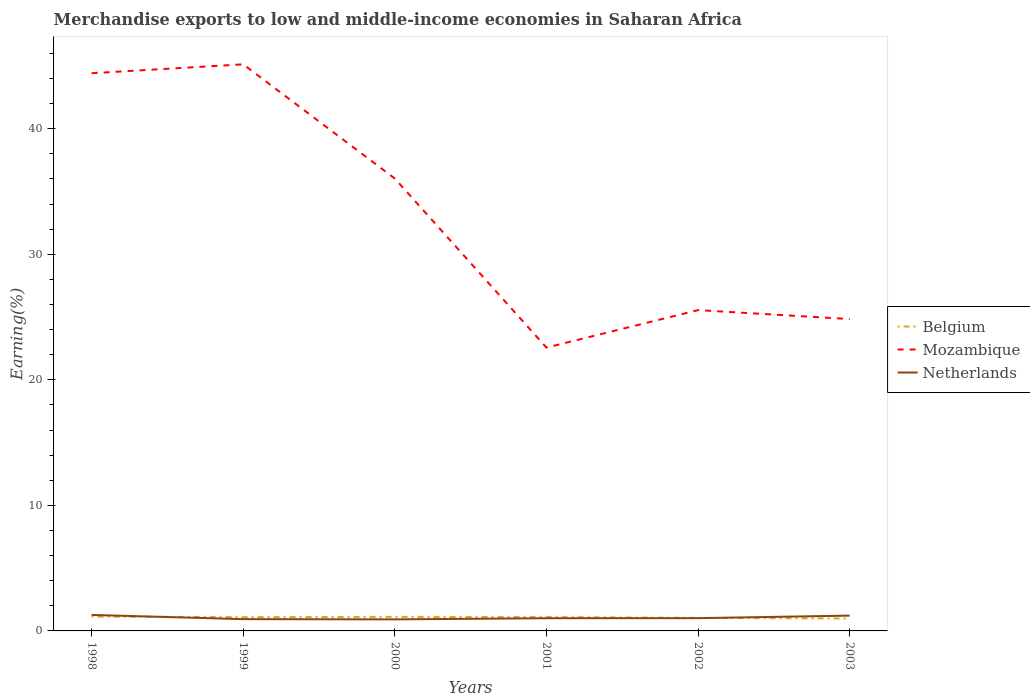Does the line corresponding to Netherlands intersect with the line corresponding to Mozambique?
Make the answer very short. No. Is the number of lines equal to the number of legend labels?
Offer a terse response. Yes. Across all years, what is the maximum percentage of amount earned from merchandise exports in Netherlands?
Keep it short and to the point. 0.92. In which year was the percentage of amount earned from merchandise exports in Belgium maximum?
Make the answer very short. 2003. What is the total percentage of amount earned from merchandise exports in Mozambique in the graph?
Your answer should be very brief. 19.58. What is the difference between the highest and the second highest percentage of amount earned from merchandise exports in Netherlands?
Your answer should be very brief. 0.35. How many lines are there?
Give a very brief answer. 3. Are the values on the major ticks of Y-axis written in scientific E-notation?
Offer a terse response. No. Does the graph contain grids?
Offer a very short reply. No. How are the legend labels stacked?
Give a very brief answer. Vertical. What is the title of the graph?
Offer a terse response. Merchandise exports to low and middle-income economies in Saharan Africa. What is the label or title of the Y-axis?
Ensure brevity in your answer.  Earning(%). What is the Earning(%) of Belgium in 1998?
Give a very brief answer. 1.15. What is the Earning(%) in Mozambique in 1998?
Your answer should be compact. 44.42. What is the Earning(%) of Netherlands in 1998?
Offer a terse response. 1.27. What is the Earning(%) of Belgium in 1999?
Your answer should be very brief. 1.09. What is the Earning(%) of Mozambique in 1999?
Give a very brief answer. 45.13. What is the Earning(%) of Netherlands in 1999?
Your answer should be compact. 0.94. What is the Earning(%) in Belgium in 2000?
Offer a very short reply. 1.12. What is the Earning(%) of Mozambique in 2000?
Keep it short and to the point. 36.03. What is the Earning(%) in Netherlands in 2000?
Give a very brief answer. 0.92. What is the Earning(%) in Belgium in 2001?
Provide a short and direct response. 1.1. What is the Earning(%) of Mozambique in 2001?
Your answer should be very brief. 22.57. What is the Earning(%) in Netherlands in 2001?
Give a very brief answer. 1.01. What is the Earning(%) in Belgium in 2002?
Provide a short and direct response. 1.04. What is the Earning(%) in Mozambique in 2002?
Provide a short and direct response. 25.55. What is the Earning(%) of Netherlands in 2002?
Ensure brevity in your answer.  1.02. What is the Earning(%) of Belgium in 2003?
Your answer should be very brief. 0.99. What is the Earning(%) in Mozambique in 2003?
Your response must be concise. 24.84. What is the Earning(%) in Netherlands in 2003?
Provide a succinct answer. 1.22. Across all years, what is the maximum Earning(%) of Belgium?
Keep it short and to the point. 1.15. Across all years, what is the maximum Earning(%) of Mozambique?
Make the answer very short. 45.13. Across all years, what is the maximum Earning(%) of Netherlands?
Provide a short and direct response. 1.27. Across all years, what is the minimum Earning(%) of Belgium?
Your response must be concise. 0.99. Across all years, what is the minimum Earning(%) in Mozambique?
Offer a terse response. 22.57. Across all years, what is the minimum Earning(%) in Netherlands?
Offer a terse response. 0.92. What is the total Earning(%) of Belgium in the graph?
Provide a short and direct response. 6.49. What is the total Earning(%) in Mozambique in the graph?
Provide a succinct answer. 198.54. What is the total Earning(%) of Netherlands in the graph?
Give a very brief answer. 6.38. What is the difference between the Earning(%) in Belgium in 1998 and that in 1999?
Offer a very short reply. 0.05. What is the difference between the Earning(%) in Mozambique in 1998 and that in 1999?
Your answer should be compact. -0.71. What is the difference between the Earning(%) of Netherlands in 1998 and that in 1999?
Offer a very short reply. 0.33. What is the difference between the Earning(%) in Belgium in 1998 and that in 2000?
Make the answer very short. 0.02. What is the difference between the Earning(%) of Mozambique in 1998 and that in 2000?
Provide a short and direct response. 8.39. What is the difference between the Earning(%) of Netherlands in 1998 and that in 2000?
Your answer should be very brief. 0.35. What is the difference between the Earning(%) in Belgium in 1998 and that in 2001?
Offer a very short reply. 0.04. What is the difference between the Earning(%) in Mozambique in 1998 and that in 2001?
Provide a short and direct response. 21.85. What is the difference between the Earning(%) of Netherlands in 1998 and that in 2001?
Your answer should be very brief. 0.26. What is the difference between the Earning(%) in Belgium in 1998 and that in 2002?
Give a very brief answer. 0.11. What is the difference between the Earning(%) in Mozambique in 1998 and that in 2002?
Offer a very short reply. 18.87. What is the difference between the Earning(%) of Netherlands in 1998 and that in 2002?
Keep it short and to the point. 0.26. What is the difference between the Earning(%) of Belgium in 1998 and that in 2003?
Make the answer very short. 0.16. What is the difference between the Earning(%) in Mozambique in 1998 and that in 2003?
Ensure brevity in your answer.  19.58. What is the difference between the Earning(%) in Netherlands in 1998 and that in 2003?
Your response must be concise. 0.05. What is the difference between the Earning(%) of Belgium in 1999 and that in 2000?
Provide a short and direct response. -0.03. What is the difference between the Earning(%) of Mozambique in 1999 and that in 2000?
Ensure brevity in your answer.  9.1. What is the difference between the Earning(%) of Netherlands in 1999 and that in 2000?
Your response must be concise. 0.02. What is the difference between the Earning(%) in Belgium in 1999 and that in 2001?
Your response must be concise. -0.01. What is the difference between the Earning(%) in Mozambique in 1999 and that in 2001?
Ensure brevity in your answer.  22.56. What is the difference between the Earning(%) of Netherlands in 1999 and that in 2001?
Keep it short and to the point. -0.07. What is the difference between the Earning(%) of Belgium in 1999 and that in 2002?
Keep it short and to the point. 0.05. What is the difference between the Earning(%) of Mozambique in 1999 and that in 2002?
Keep it short and to the point. 19.58. What is the difference between the Earning(%) in Netherlands in 1999 and that in 2002?
Offer a very short reply. -0.08. What is the difference between the Earning(%) of Belgium in 1999 and that in 2003?
Make the answer very short. 0.11. What is the difference between the Earning(%) of Mozambique in 1999 and that in 2003?
Provide a succinct answer. 20.29. What is the difference between the Earning(%) of Netherlands in 1999 and that in 2003?
Make the answer very short. -0.28. What is the difference between the Earning(%) in Belgium in 2000 and that in 2001?
Your answer should be very brief. 0.02. What is the difference between the Earning(%) of Mozambique in 2000 and that in 2001?
Provide a succinct answer. 13.46. What is the difference between the Earning(%) in Netherlands in 2000 and that in 2001?
Offer a very short reply. -0.09. What is the difference between the Earning(%) of Belgium in 2000 and that in 2002?
Provide a short and direct response. 0.08. What is the difference between the Earning(%) of Mozambique in 2000 and that in 2002?
Your answer should be very brief. 10.48. What is the difference between the Earning(%) in Netherlands in 2000 and that in 2002?
Offer a terse response. -0.1. What is the difference between the Earning(%) of Belgium in 2000 and that in 2003?
Your response must be concise. 0.13. What is the difference between the Earning(%) in Mozambique in 2000 and that in 2003?
Provide a succinct answer. 11.19. What is the difference between the Earning(%) in Netherlands in 2000 and that in 2003?
Give a very brief answer. -0.3. What is the difference between the Earning(%) in Belgium in 2001 and that in 2002?
Provide a succinct answer. 0.06. What is the difference between the Earning(%) of Mozambique in 2001 and that in 2002?
Provide a short and direct response. -2.98. What is the difference between the Earning(%) in Netherlands in 2001 and that in 2002?
Keep it short and to the point. -0.01. What is the difference between the Earning(%) of Belgium in 2001 and that in 2003?
Offer a terse response. 0.11. What is the difference between the Earning(%) in Mozambique in 2001 and that in 2003?
Provide a succinct answer. -2.27. What is the difference between the Earning(%) in Netherlands in 2001 and that in 2003?
Make the answer very short. -0.21. What is the difference between the Earning(%) of Belgium in 2002 and that in 2003?
Your response must be concise. 0.05. What is the difference between the Earning(%) of Mozambique in 2002 and that in 2003?
Your response must be concise. 0.71. What is the difference between the Earning(%) of Netherlands in 2002 and that in 2003?
Keep it short and to the point. -0.2. What is the difference between the Earning(%) of Belgium in 1998 and the Earning(%) of Mozambique in 1999?
Give a very brief answer. -43.98. What is the difference between the Earning(%) in Belgium in 1998 and the Earning(%) in Netherlands in 1999?
Provide a succinct answer. 0.21. What is the difference between the Earning(%) in Mozambique in 1998 and the Earning(%) in Netherlands in 1999?
Keep it short and to the point. 43.48. What is the difference between the Earning(%) in Belgium in 1998 and the Earning(%) in Mozambique in 2000?
Make the answer very short. -34.89. What is the difference between the Earning(%) in Belgium in 1998 and the Earning(%) in Netherlands in 2000?
Offer a very short reply. 0.23. What is the difference between the Earning(%) in Mozambique in 1998 and the Earning(%) in Netherlands in 2000?
Your response must be concise. 43.5. What is the difference between the Earning(%) of Belgium in 1998 and the Earning(%) of Mozambique in 2001?
Your response must be concise. -21.42. What is the difference between the Earning(%) in Belgium in 1998 and the Earning(%) in Netherlands in 2001?
Ensure brevity in your answer.  0.13. What is the difference between the Earning(%) of Mozambique in 1998 and the Earning(%) of Netherlands in 2001?
Provide a short and direct response. 43.41. What is the difference between the Earning(%) of Belgium in 1998 and the Earning(%) of Mozambique in 2002?
Your answer should be compact. -24.41. What is the difference between the Earning(%) in Belgium in 1998 and the Earning(%) in Netherlands in 2002?
Provide a short and direct response. 0.13. What is the difference between the Earning(%) of Mozambique in 1998 and the Earning(%) of Netherlands in 2002?
Ensure brevity in your answer.  43.4. What is the difference between the Earning(%) of Belgium in 1998 and the Earning(%) of Mozambique in 2003?
Ensure brevity in your answer.  -23.69. What is the difference between the Earning(%) in Belgium in 1998 and the Earning(%) in Netherlands in 2003?
Keep it short and to the point. -0.07. What is the difference between the Earning(%) in Mozambique in 1998 and the Earning(%) in Netherlands in 2003?
Keep it short and to the point. 43.2. What is the difference between the Earning(%) in Belgium in 1999 and the Earning(%) in Mozambique in 2000?
Your answer should be very brief. -34.94. What is the difference between the Earning(%) of Belgium in 1999 and the Earning(%) of Netherlands in 2000?
Ensure brevity in your answer.  0.17. What is the difference between the Earning(%) in Mozambique in 1999 and the Earning(%) in Netherlands in 2000?
Your response must be concise. 44.21. What is the difference between the Earning(%) of Belgium in 1999 and the Earning(%) of Mozambique in 2001?
Your response must be concise. -21.48. What is the difference between the Earning(%) in Belgium in 1999 and the Earning(%) in Netherlands in 2001?
Offer a very short reply. 0.08. What is the difference between the Earning(%) of Mozambique in 1999 and the Earning(%) of Netherlands in 2001?
Give a very brief answer. 44.12. What is the difference between the Earning(%) of Belgium in 1999 and the Earning(%) of Mozambique in 2002?
Keep it short and to the point. -24.46. What is the difference between the Earning(%) in Belgium in 1999 and the Earning(%) in Netherlands in 2002?
Ensure brevity in your answer.  0.08. What is the difference between the Earning(%) in Mozambique in 1999 and the Earning(%) in Netherlands in 2002?
Ensure brevity in your answer.  44.11. What is the difference between the Earning(%) of Belgium in 1999 and the Earning(%) of Mozambique in 2003?
Provide a short and direct response. -23.75. What is the difference between the Earning(%) in Belgium in 1999 and the Earning(%) in Netherlands in 2003?
Offer a terse response. -0.13. What is the difference between the Earning(%) in Mozambique in 1999 and the Earning(%) in Netherlands in 2003?
Provide a short and direct response. 43.91. What is the difference between the Earning(%) in Belgium in 2000 and the Earning(%) in Mozambique in 2001?
Keep it short and to the point. -21.45. What is the difference between the Earning(%) of Belgium in 2000 and the Earning(%) of Netherlands in 2001?
Provide a short and direct response. 0.11. What is the difference between the Earning(%) in Mozambique in 2000 and the Earning(%) in Netherlands in 2001?
Your answer should be very brief. 35.02. What is the difference between the Earning(%) in Belgium in 2000 and the Earning(%) in Mozambique in 2002?
Provide a short and direct response. -24.43. What is the difference between the Earning(%) in Belgium in 2000 and the Earning(%) in Netherlands in 2002?
Your answer should be compact. 0.1. What is the difference between the Earning(%) in Mozambique in 2000 and the Earning(%) in Netherlands in 2002?
Provide a short and direct response. 35.01. What is the difference between the Earning(%) of Belgium in 2000 and the Earning(%) of Mozambique in 2003?
Offer a very short reply. -23.72. What is the difference between the Earning(%) in Belgium in 2000 and the Earning(%) in Netherlands in 2003?
Provide a succinct answer. -0.1. What is the difference between the Earning(%) of Mozambique in 2000 and the Earning(%) of Netherlands in 2003?
Offer a terse response. 34.81. What is the difference between the Earning(%) of Belgium in 2001 and the Earning(%) of Mozambique in 2002?
Your answer should be very brief. -24.45. What is the difference between the Earning(%) in Belgium in 2001 and the Earning(%) in Netherlands in 2002?
Provide a short and direct response. 0.08. What is the difference between the Earning(%) of Mozambique in 2001 and the Earning(%) of Netherlands in 2002?
Your answer should be compact. 21.55. What is the difference between the Earning(%) of Belgium in 2001 and the Earning(%) of Mozambique in 2003?
Provide a succinct answer. -23.74. What is the difference between the Earning(%) in Belgium in 2001 and the Earning(%) in Netherlands in 2003?
Offer a terse response. -0.12. What is the difference between the Earning(%) of Mozambique in 2001 and the Earning(%) of Netherlands in 2003?
Make the answer very short. 21.35. What is the difference between the Earning(%) of Belgium in 2002 and the Earning(%) of Mozambique in 2003?
Provide a short and direct response. -23.8. What is the difference between the Earning(%) of Belgium in 2002 and the Earning(%) of Netherlands in 2003?
Make the answer very short. -0.18. What is the difference between the Earning(%) of Mozambique in 2002 and the Earning(%) of Netherlands in 2003?
Your answer should be compact. 24.33. What is the average Earning(%) in Belgium per year?
Give a very brief answer. 1.08. What is the average Earning(%) of Mozambique per year?
Ensure brevity in your answer.  33.09. What is the average Earning(%) of Netherlands per year?
Keep it short and to the point. 1.06. In the year 1998, what is the difference between the Earning(%) in Belgium and Earning(%) in Mozambique?
Make the answer very short. -43.28. In the year 1998, what is the difference between the Earning(%) of Belgium and Earning(%) of Netherlands?
Give a very brief answer. -0.13. In the year 1998, what is the difference between the Earning(%) of Mozambique and Earning(%) of Netherlands?
Offer a very short reply. 43.15. In the year 1999, what is the difference between the Earning(%) of Belgium and Earning(%) of Mozambique?
Provide a short and direct response. -44.04. In the year 1999, what is the difference between the Earning(%) in Belgium and Earning(%) in Netherlands?
Ensure brevity in your answer.  0.15. In the year 1999, what is the difference between the Earning(%) in Mozambique and Earning(%) in Netherlands?
Provide a succinct answer. 44.19. In the year 2000, what is the difference between the Earning(%) in Belgium and Earning(%) in Mozambique?
Offer a terse response. -34.91. In the year 2000, what is the difference between the Earning(%) in Belgium and Earning(%) in Netherlands?
Offer a terse response. 0.2. In the year 2000, what is the difference between the Earning(%) of Mozambique and Earning(%) of Netherlands?
Offer a terse response. 35.11. In the year 2001, what is the difference between the Earning(%) in Belgium and Earning(%) in Mozambique?
Offer a terse response. -21.47. In the year 2001, what is the difference between the Earning(%) of Belgium and Earning(%) of Netherlands?
Offer a terse response. 0.09. In the year 2001, what is the difference between the Earning(%) of Mozambique and Earning(%) of Netherlands?
Provide a short and direct response. 21.56. In the year 2002, what is the difference between the Earning(%) of Belgium and Earning(%) of Mozambique?
Offer a very short reply. -24.51. In the year 2002, what is the difference between the Earning(%) in Belgium and Earning(%) in Netherlands?
Make the answer very short. 0.02. In the year 2002, what is the difference between the Earning(%) of Mozambique and Earning(%) of Netherlands?
Your answer should be compact. 24.53. In the year 2003, what is the difference between the Earning(%) in Belgium and Earning(%) in Mozambique?
Keep it short and to the point. -23.85. In the year 2003, what is the difference between the Earning(%) of Belgium and Earning(%) of Netherlands?
Keep it short and to the point. -0.23. In the year 2003, what is the difference between the Earning(%) in Mozambique and Earning(%) in Netherlands?
Give a very brief answer. 23.62. What is the ratio of the Earning(%) in Belgium in 1998 to that in 1999?
Ensure brevity in your answer.  1.05. What is the ratio of the Earning(%) of Mozambique in 1998 to that in 1999?
Provide a succinct answer. 0.98. What is the ratio of the Earning(%) in Netherlands in 1998 to that in 1999?
Give a very brief answer. 1.36. What is the ratio of the Earning(%) in Belgium in 1998 to that in 2000?
Your answer should be very brief. 1.02. What is the ratio of the Earning(%) in Mozambique in 1998 to that in 2000?
Give a very brief answer. 1.23. What is the ratio of the Earning(%) in Netherlands in 1998 to that in 2000?
Provide a short and direct response. 1.39. What is the ratio of the Earning(%) in Belgium in 1998 to that in 2001?
Ensure brevity in your answer.  1.04. What is the ratio of the Earning(%) of Mozambique in 1998 to that in 2001?
Keep it short and to the point. 1.97. What is the ratio of the Earning(%) of Netherlands in 1998 to that in 2001?
Provide a short and direct response. 1.26. What is the ratio of the Earning(%) of Belgium in 1998 to that in 2002?
Give a very brief answer. 1.1. What is the ratio of the Earning(%) of Mozambique in 1998 to that in 2002?
Give a very brief answer. 1.74. What is the ratio of the Earning(%) in Netherlands in 1998 to that in 2002?
Ensure brevity in your answer.  1.25. What is the ratio of the Earning(%) in Belgium in 1998 to that in 2003?
Make the answer very short. 1.16. What is the ratio of the Earning(%) in Mozambique in 1998 to that in 2003?
Offer a very short reply. 1.79. What is the ratio of the Earning(%) of Netherlands in 1998 to that in 2003?
Make the answer very short. 1.04. What is the ratio of the Earning(%) in Belgium in 1999 to that in 2000?
Provide a succinct answer. 0.98. What is the ratio of the Earning(%) of Mozambique in 1999 to that in 2000?
Offer a terse response. 1.25. What is the ratio of the Earning(%) in Netherlands in 1999 to that in 2000?
Give a very brief answer. 1.02. What is the ratio of the Earning(%) in Belgium in 1999 to that in 2001?
Offer a terse response. 0.99. What is the ratio of the Earning(%) in Mozambique in 1999 to that in 2001?
Your response must be concise. 2. What is the ratio of the Earning(%) of Netherlands in 1999 to that in 2001?
Ensure brevity in your answer.  0.93. What is the ratio of the Earning(%) in Belgium in 1999 to that in 2002?
Make the answer very short. 1.05. What is the ratio of the Earning(%) in Mozambique in 1999 to that in 2002?
Ensure brevity in your answer.  1.77. What is the ratio of the Earning(%) of Netherlands in 1999 to that in 2002?
Give a very brief answer. 0.92. What is the ratio of the Earning(%) in Belgium in 1999 to that in 2003?
Offer a terse response. 1.11. What is the ratio of the Earning(%) of Mozambique in 1999 to that in 2003?
Keep it short and to the point. 1.82. What is the ratio of the Earning(%) in Netherlands in 1999 to that in 2003?
Keep it short and to the point. 0.77. What is the ratio of the Earning(%) in Belgium in 2000 to that in 2001?
Provide a succinct answer. 1.02. What is the ratio of the Earning(%) of Mozambique in 2000 to that in 2001?
Ensure brevity in your answer.  1.6. What is the ratio of the Earning(%) in Netherlands in 2000 to that in 2001?
Provide a short and direct response. 0.91. What is the ratio of the Earning(%) of Belgium in 2000 to that in 2002?
Provide a succinct answer. 1.08. What is the ratio of the Earning(%) of Mozambique in 2000 to that in 2002?
Keep it short and to the point. 1.41. What is the ratio of the Earning(%) of Netherlands in 2000 to that in 2002?
Keep it short and to the point. 0.9. What is the ratio of the Earning(%) in Belgium in 2000 to that in 2003?
Offer a very short reply. 1.13. What is the ratio of the Earning(%) in Mozambique in 2000 to that in 2003?
Keep it short and to the point. 1.45. What is the ratio of the Earning(%) in Netherlands in 2000 to that in 2003?
Ensure brevity in your answer.  0.75. What is the ratio of the Earning(%) in Belgium in 2001 to that in 2002?
Make the answer very short. 1.06. What is the ratio of the Earning(%) in Mozambique in 2001 to that in 2002?
Offer a terse response. 0.88. What is the ratio of the Earning(%) in Netherlands in 2001 to that in 2002?
Ensure brevity in your answer.  0.99. What is the ratio of the Earning(%) of Belgium in 2001 to that in 2003?
Offer a very short reply. 1.12. What is the ratio of the Earning(%) of Mozambique in 2001 to that in 2003?
Your answer should be compact. 0.91. What is the ratio of the Earning(%) in Netherlands in 2001 to that in 2003?
Ensure brevity in your answer.  0.83. What is the ratio of the Earning(%) of Belgium in 2002 to that in 2003?
Give a very brief answer. 1.05. What is the ratio of the Earning(%) in Mozambique in 2002 to that in 2003?
Ensure brevity in your answer.  1.03. What is the ratio of the Earning(%) in Netherlands in 2002 to that in 2003?
Make the answer very short. 0.83. What is the difference between the highest and the second highest Earning(%) of Belgium?
Give a very brief answer. 0.02. What is the difference between the highest and the second highest Earning(%) in Mozambique?
Keep it short and to the point. 0.71. What is the difference between the highest and the second highest Earning(%) of Netherlands?
Offer a terse response. 0.05. What is the difference between the highest and the lowest Earning(%) of Belgium?
Your answer should be very brief. 0.16. What is the difference between the highest and the lowest Earning(%) in Mozambique?
Ensure brevity in your answer.  22.56. What is the difference between the highest and the lowest Earning(%) of Netherlands?
Provide a succinct answer. 0.35. 